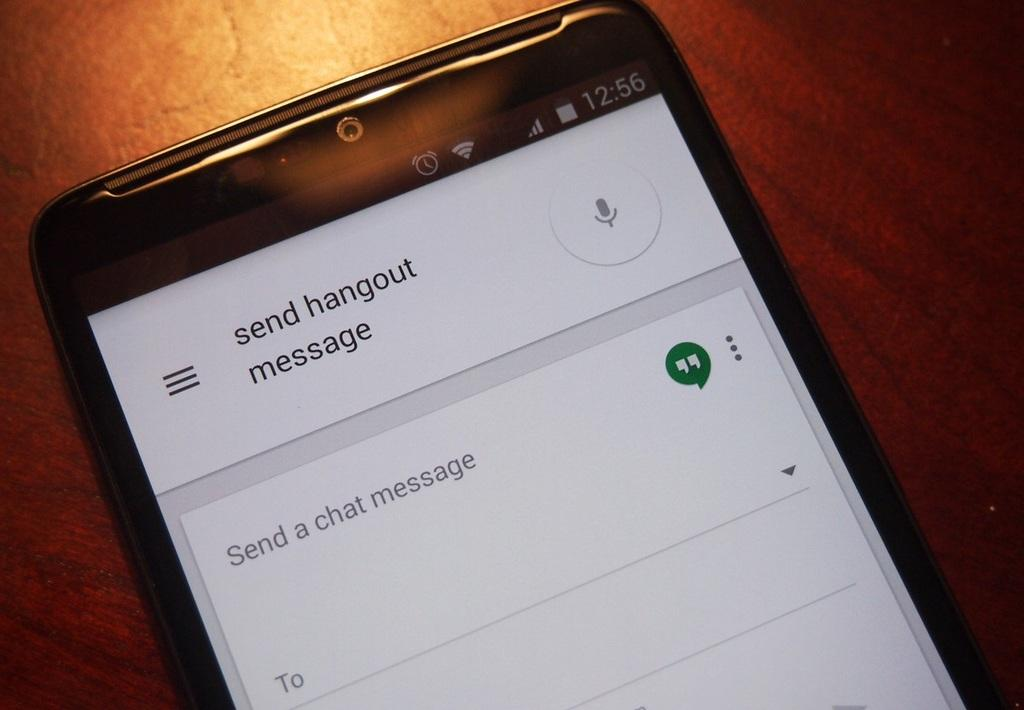<image>
Render a clear and concise summary of the photo. a phone settings page where send hangout is at the top 